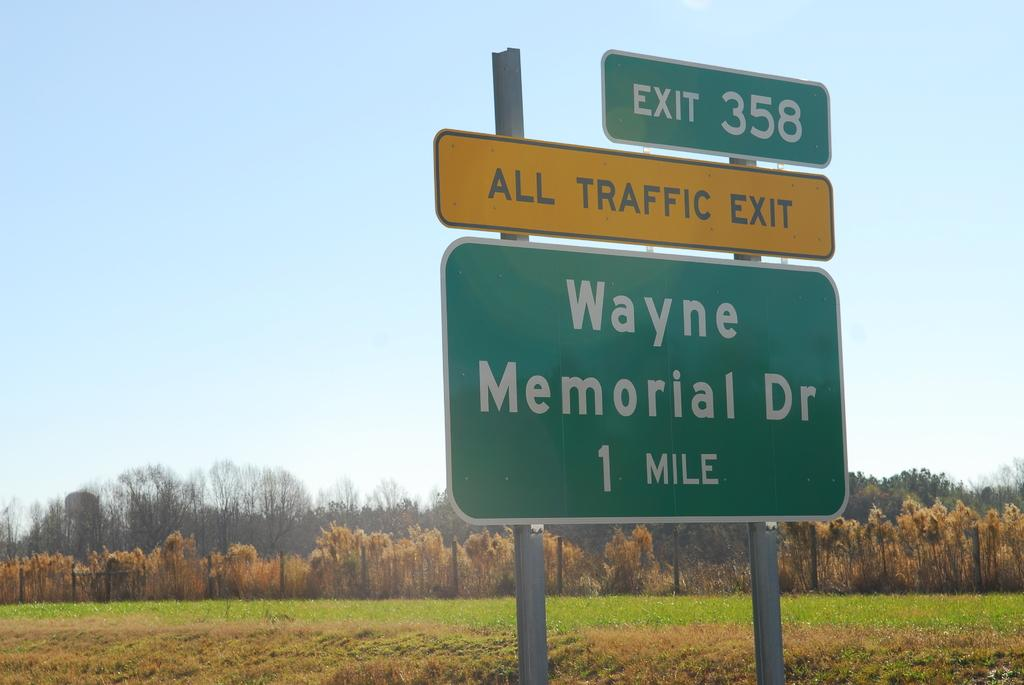<image>
Summarize the visual content of the image. A green sign marking the exit 358 and Wayne Memorial dr 